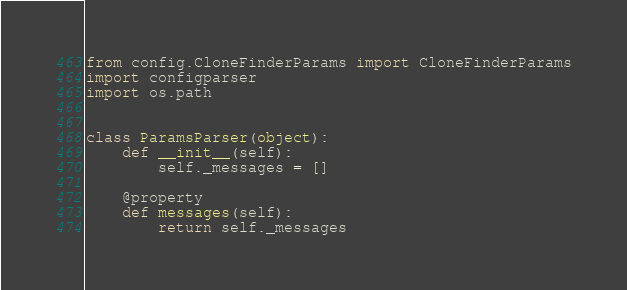<code> <loc_0><loc_0><loc_500><loc_500><_Python_>from config.CloneFinderParams import CloneFinderParams
import configparser
import os.path


class ParamsParser(object):
    def __init__(self):
        self._messages = []

    @property
    def messages(self):
        return self._messages
</code> 